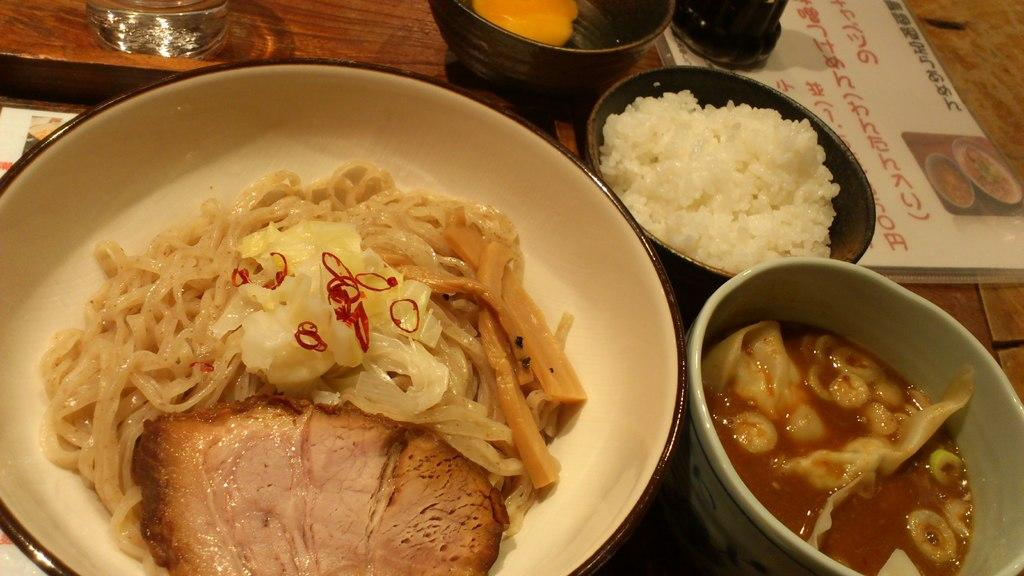What is the main object in the center of the image? There is a table in the center of the image. What can be found on the table? On the table, there is a plate and bowls. What type of items are on the table? There are food items and other objects on the table. How many grapes are on the table in the image? There is no mention of grapes in the image, so it is impossible to determine the number of grapes present. What type of fruit is the quince in the image? There is no quince present in the image. 